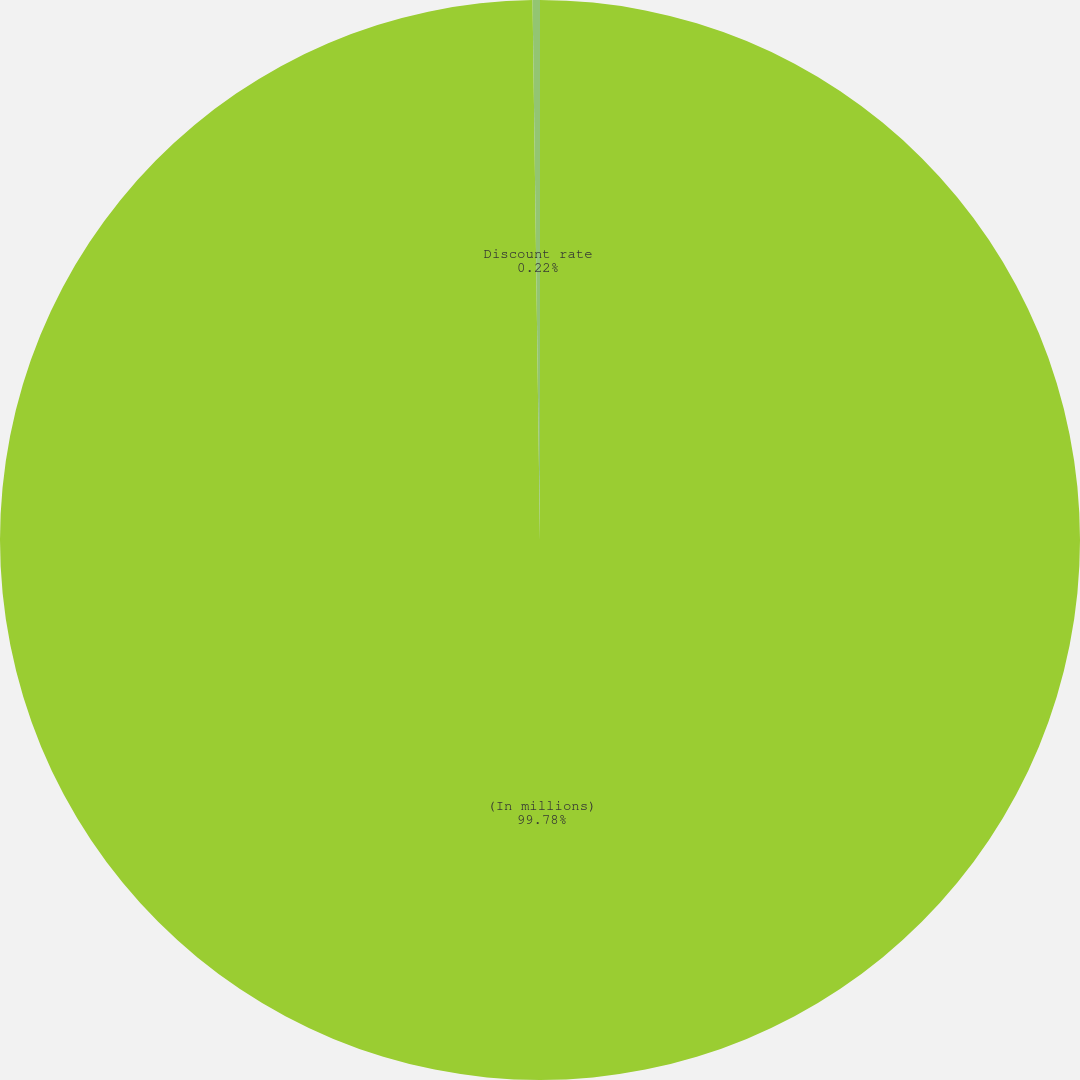Convert chart. <chart><loc_0><loc_0><loc_500><loc_500><pie_chart><fcel>(In millions)<fcel>Discount rate<nl><fcel>99.78%<fcel>0.22%<nl></chart> 